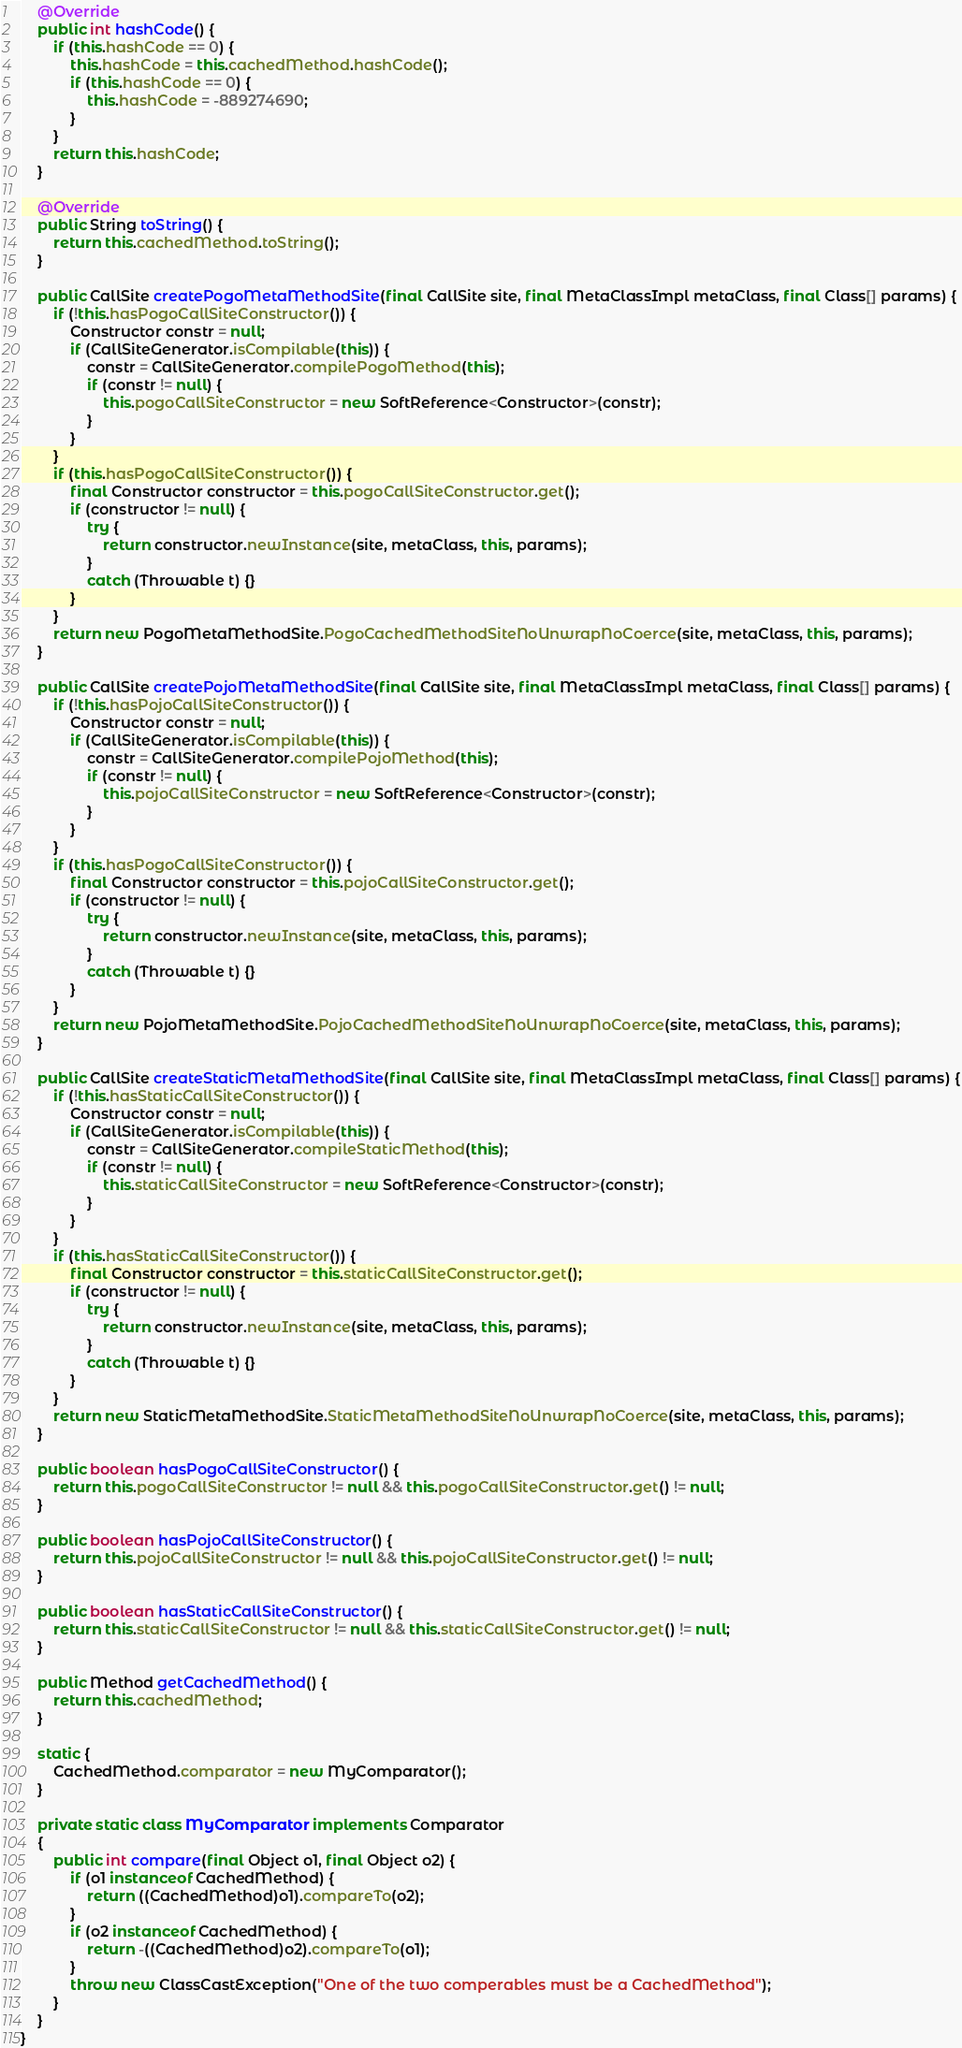<code> <loc_0><loc_0><loc_500><loc_500><_Java_>    @Override
    public int hashCode() {
        if (this.hashCode == 0) {
            this.hashCode = this.cachedMethod.hashCode();
            if (this.hashCode == 0) {
                this.hashCode = -889274690;
            }
        }
        return this.hashCode;
    }
    
    @Override
    public String toString() {
        return this.cachedMethod.toString();
    }
    
    public CallSite createPogoMetaMethodSite(final CallSite site, final MetaClassImpl metaClass, final Class[] params) {
        if (!this.hasPogoCallSiteConstructor()) {
            Constructor constr = null;
            if (CallSiteGenerator.isCompilable(this)) {
                constr = CallSiteGenerator.compilePogoMethod(this);
                if (constr != null) {
                    this.pogoCallSiteConstructor = new SoftReference<Constructor>(constr);
                }
            }
        }
        if (this.hasPogoCallSiteConstructor()) {
            final Constructor constructor = this.pogoCallSiteConstructor.get();
            if (constructor != null) {
                try {
                    return constructor.newInstance(site, metaClass, this, params);
                }
                catch (Throwable t) {}
            }
        }
        return new PogoMetaMethodSite.PogoCachedMethodSiteNoUnwrapNoCoerce(site, metaClass, this, params);
    }
    
    public CallSite createPojoMetaMethodSite(final CallSite site, final MetaClassImpl metaClass, final Class[] params) {
        if (!this.hasPojoCallSiteConstructor()) {
            Constructor constr = null;
            if (CallSiteGenerator.isCompilable(this)) {
                constr = CallSiteGenerator.compilePojoMethod(this);
                if (constr != null) {
                    this.pojoCallSiteConstructor = new SoftReference<Constructor>(constr);
                }
            }
        }
        if (this.hasPogoCallSiteConstructor()) {
            final Constructor constructor = this.pojoCallSiteConstructor.get();
            if (constructor != null) {
                try {
                    return constructor.newInstance(site, metaClass, this, params);
                }
                catch (Throwable t) {}
            }
        }
        return new PojoMetaMethodSite.PojoCachedMethodSiteNoUnwrapNoCoerce(site, metaClass, this, params);
    }
    
    public CallSite createStaticMetaMethodSite(final CallSite site, final MetaClassImpl metaClass, final Class[] params) {
        if (!this.hasStaticCallSiteConstructor()) {
            Constructor constr = null;
            if (CallSiteGenerator.isCompilable(this)) {
                constr = CallSiteGenerator.compileStaticMethod(this);
                if (constr != null) {
                    this.staticCallSiteConstructor = new SoftReference<Constructor>(constr);
                }
            }
        }
        if (this.hasStaticCallSiteConstructor()) {
            final Constructor constructor = this.staticCallSiteConstructor.get();
            if (constructor != null) {
                try {
                    return constructor.newInstance(site, metaClass, this, params);
                }
                catch (Throwable t) {}
            }
        }
        return new StaticMetaMethodSite.StaticMetaMethodSiteNoUnwrapNoCoerce(site, metaClass, this, params);
    }
    
    public boolean hasPogoCallSiteConstructor() {
        return this.pogoCallSiteConstructor != null && this.pogoCallSiteConstructor.get() != null;
    }
    
    public boolean hasPojoCallSiteConstructor() {
        return this.pojoCallSiteConstructor != null && this.pojoCallSiteConstructor.get() != null;
    }
    
    public boolean hasStaticCallSiteConstructor() {
        return this.staticCallSiteConstructor != null && this.staticCallSiteConstructor.get() != null;
    }
    
    public Method getCachedMethod() {
        return this.cachedMethod;
    }
    
    static {
        CachedMethod.comparator = new MyComparator();
    }
    
    private static class MyComparator implements Comparator
    {
        public int compare(final Object o1, final Object o2) {
            if (o1 instanceof CachedMethod) {
                return ((CachedMethod)o1).compareTo(o2);
            }
            if (o2 instanceof CachedMethod) {
                return -((CachedMethod)o2).compareTo(o1);
            }
            throw new ClassCastException("One of the two comperables must be a CachedMethod");
        }
    }
}
</code> 